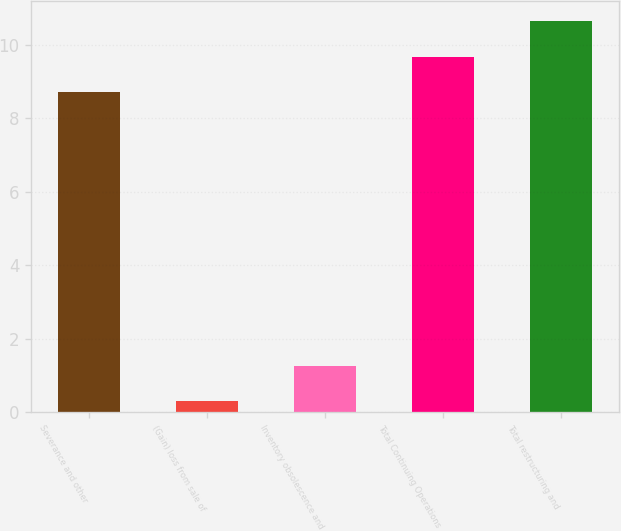Convert chart. <chart><loc_0><loc_0><loc_500><loc_500><bar_chart><fcel>Severance and other<fcel>(Gain) loss from sale of<fcel>Inventory obsolescence and<fcel>Total Continuing Operations<fcel>Total restructuring and<nl><fcel>8.7<fcel>0.3<fcel>1.27<fcel>9.67<fcel>10.64<nl></chart> 